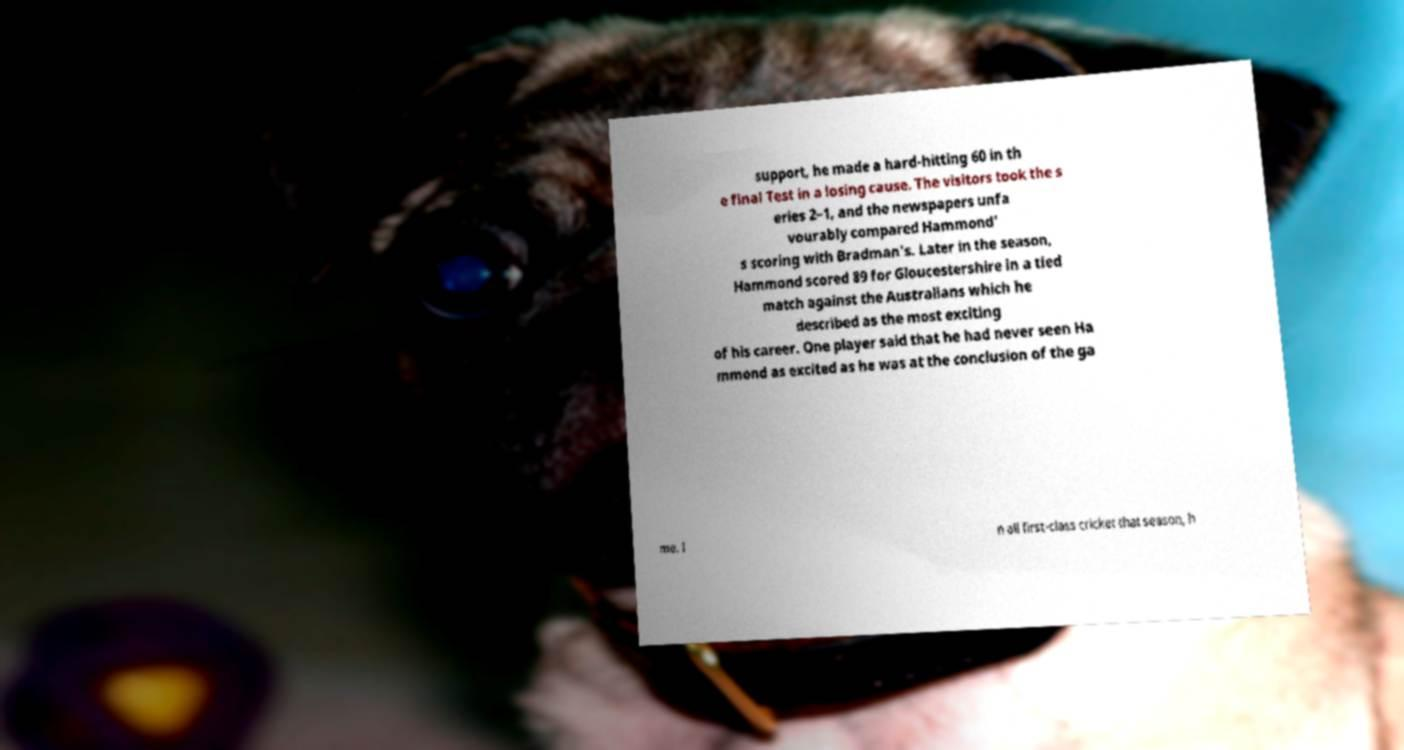Could you extract and type out the text from this image? support, he made a hard-hitting 60 in th e final Test in a losing cause. The visitors took the s eries 2–1, and the newspapers unfa vourably compared Hammond' s scoring with Bradman's. Later in the season, Hammond scored 89 for Gloucestershire in a tied match against the Australians which he described as the most exciting of his career. One player said that he had never seen Ha mmond as excited as he was at the conclusion of the ga me. I n all first-class cricket that season, h 